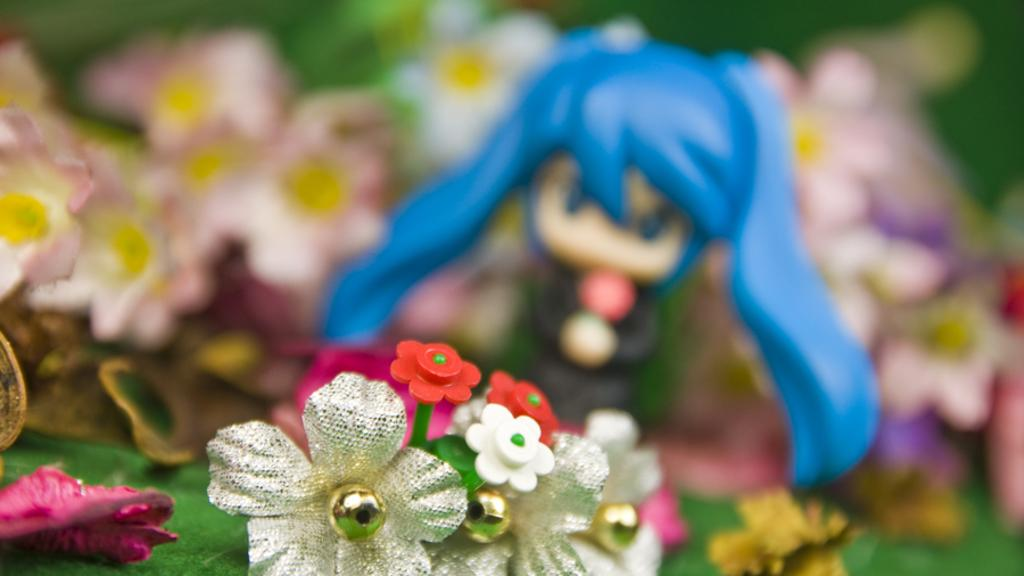What type of object is in the picture? There is a toy in the picture. What specific type of toy can be seen? There are toy flowers in the picture. Can you describe the background of the image? The background of the image is blurred. What type of net is being used to catch the beetle in the image? There is no net or beetle present in the image; it features a toy with toy flowers. What position is the beetle in the image? There is no beetle present in the image, so its position cannot be determined. 